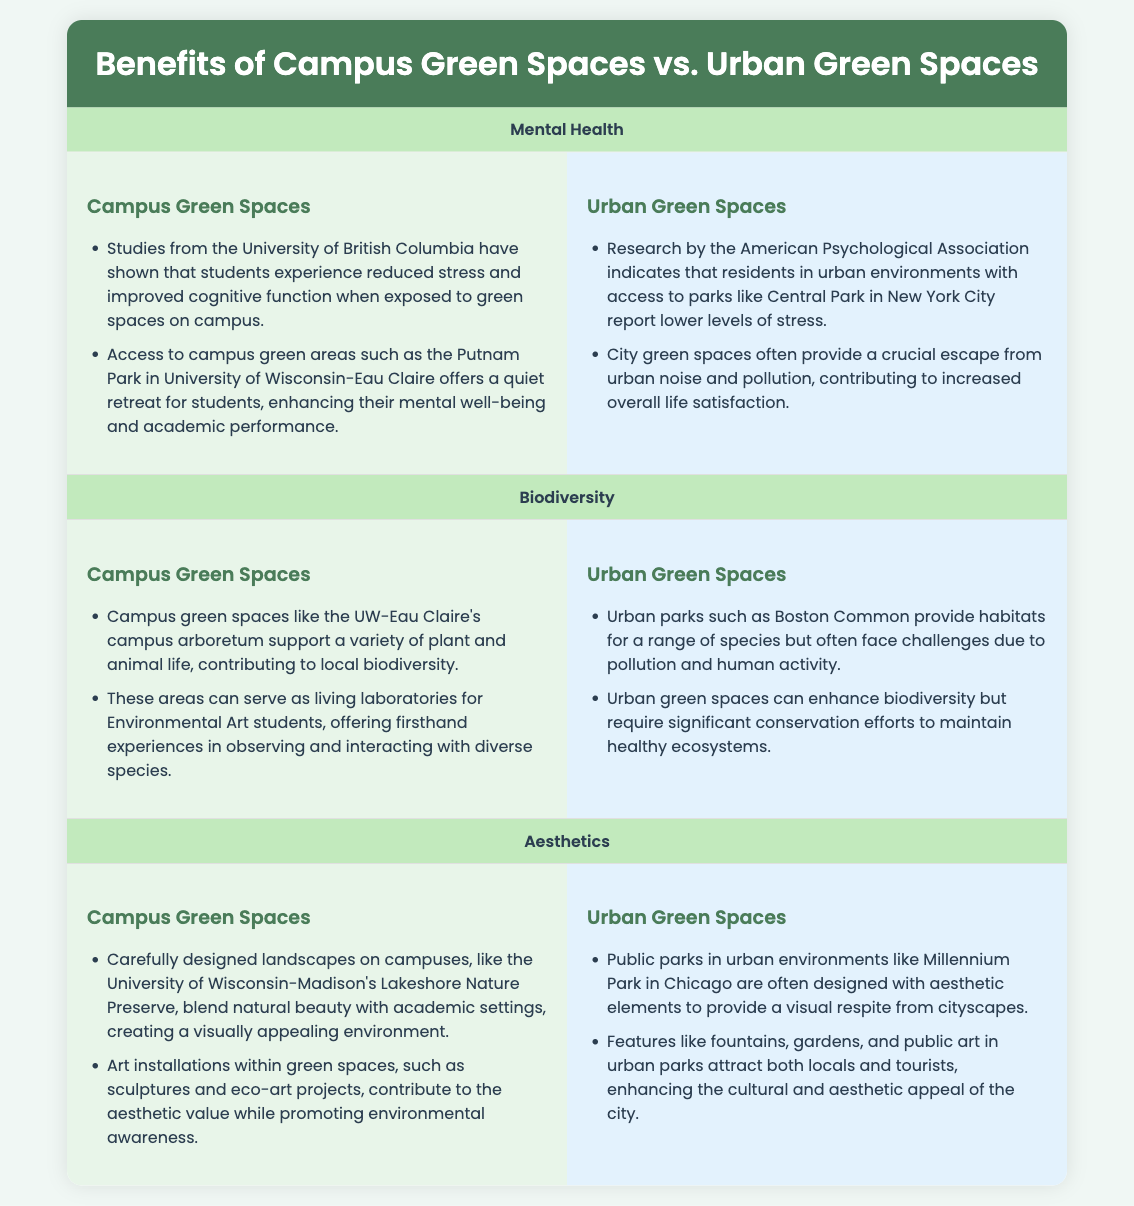what is one benefit of campus green spaces for mental health? Campus green spaces help reduce stress and improve cognitive function as indicated by studies from the University of British Columbia.
Answer: reduced stress what type of areas provide crucial escapes from urban noise? Urban green spaces serve as getaways from the hustle and bustle of city life and its accompanying noise and pollution.
Answer: parks which campus green space showcases biodiversity? The UW-Eau Claire's campus arboretum is mentioned as supporting a variety of plant and animal life.
Answer: campus arboretum what aesthetic feature is included in urban parks? Urban parks often include public art, gardens, and fountains to enhance their visual appeal.
Answer: public art how do urban green spaces impact biodiversity? Urban green spaces can enhance biodiversity but face challenges from pollution and human activity.
Answer: challenges what is one example of a campus green space mentioned? Putnam Park at the University of Wisconsin-Eau Claire is a noted green area for students.
Answer: Putnam Park what do art installations in campus green spaces promote? Art installations contribute to aesthetic value while also promoting environmental awareness in the community.
Answer: environmental awareness which park in New York City is mentioned regarding urban green spaces? Central Park is cited in the document as an example of an urban park impacting residents' well-being.
Answer: Central Park 